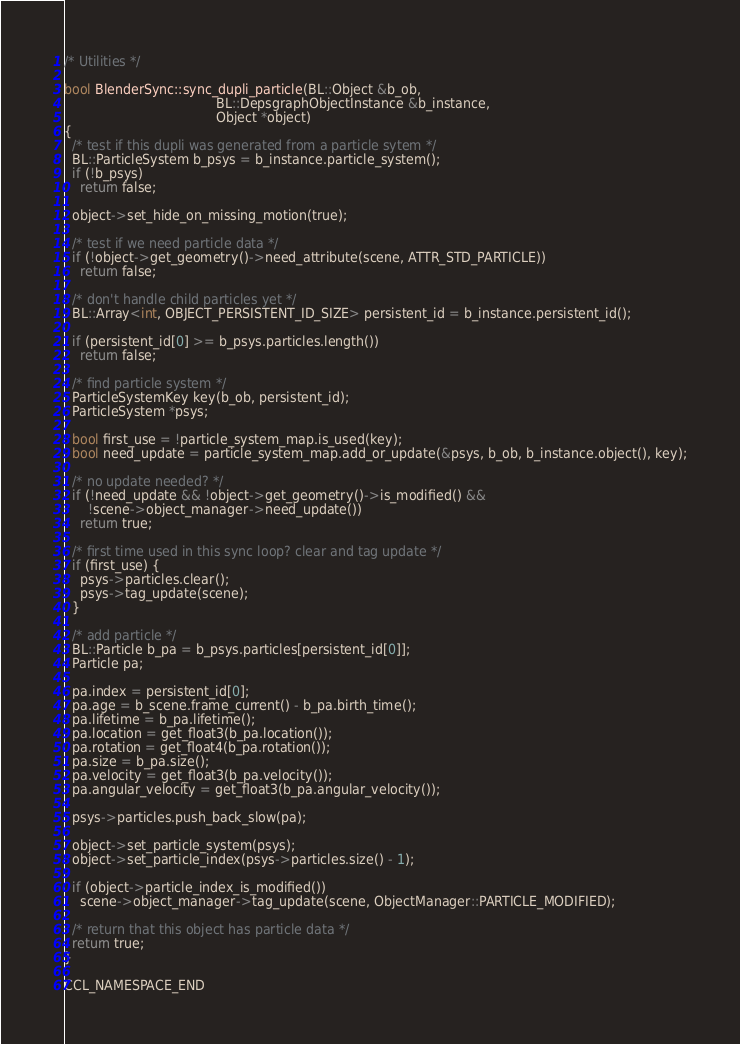Convert code to text. <code><loc_0><loc_0><loc_500><loc_500><_C++_>
/* Utilities */

bool BlenderSync::sync_dupli_particle(BL::Object &b_ob,
                                      BL::DepsgraphObjectInstance &b_instance,
                                      Object *object)
{
  /* test if this dupli was generated from a particle sytem */
  BL::ParticleSystem b_psys = b_instance.particle_system();
  if (!b_psys)
    return false;

  object->set_hide_on_missing_motion(true);

  /* test if we need particle data */
  if (!object->get_geometry()->need_attribute(scene, ATTR_STD_PARTICLE))
    return false;

  /* don't handle child particles yet */
  BL::Array<int, OBJECT_PERSISTENT_ID_SIZE> persistent_id = b_instance.persistent_id();

  if (persistent_id[0] >= b_psys.particles.length())
    return false;

  /* find particle system */
  ParticleSystemKey key(b_ob, persistent_id);
  ParticleSystem *psys;

  bool first_use = !particle_system_map.is_used(key);
  bool need_update = particle_system_map.add_or_update(&psys, b_ob, b_instance.object(), key);

  /* no update needed? */
  if (!need_update && !object->get_geometry()->is_modified() &&
      !scene->object_manager->need_update())
    return true;

  /* first time used in this sync loop? clear and tag update */
  if (first_use) {
    psys->particles.clear();
    psys->tag_update(scene);
  }

  /* add particle */
  BL::Particle b_pa = b_psys.particles[persistent_id[0]];
  Particle pa;

  pa.index = persistent_id[0];
  pa.age = b_scene.frame_current() - b_pa.birth_time();
  pa.lifetime = b_pa.lifetime();
  pa.location = get_float3(b_pa.location());
  pa.rotation = get_float4(b_pa.rotation());
  pa.size = b_pa.size();
  pa.velocity = get_float3(b_pa.velocity());
  pa.angular_velocity = get_float3(b_pa.angular_velocity());

  psys->particles.push_back_slow(pa);

  object->set_particle_system(psys);
  object->set_particle_index(psys->particles.size() - 1);

  if (object->particle_index_is_modified())
    scene->object_manager->tag_update(scene, ObjectManager::PARTICLE_MODIFIED);

  /* return that this object has particle data */
  return true;
}

CCL_NAMESPACE_END
</code> 